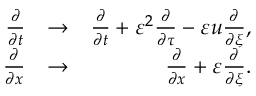Convert formula to latex. <formula><loc_0><loc_0><loc_500><loc_500>\begin{array} { r l r } { \frac { \partial } { \partial t } } & { \to } & { \frac { \partial } { \partial t } + \varepsilon ^ { 2 } \frac { \partial } { \partial \tau } - \varepsilon u \frac { \partial } { \partial \xi } , } \\ { \frac { \partial } { \partial x } } & { \to } & { \frac { \partial } { \partial x } + \varepsilon \frac { \partial } { \partial \xi } . } \end{array}</formula> 